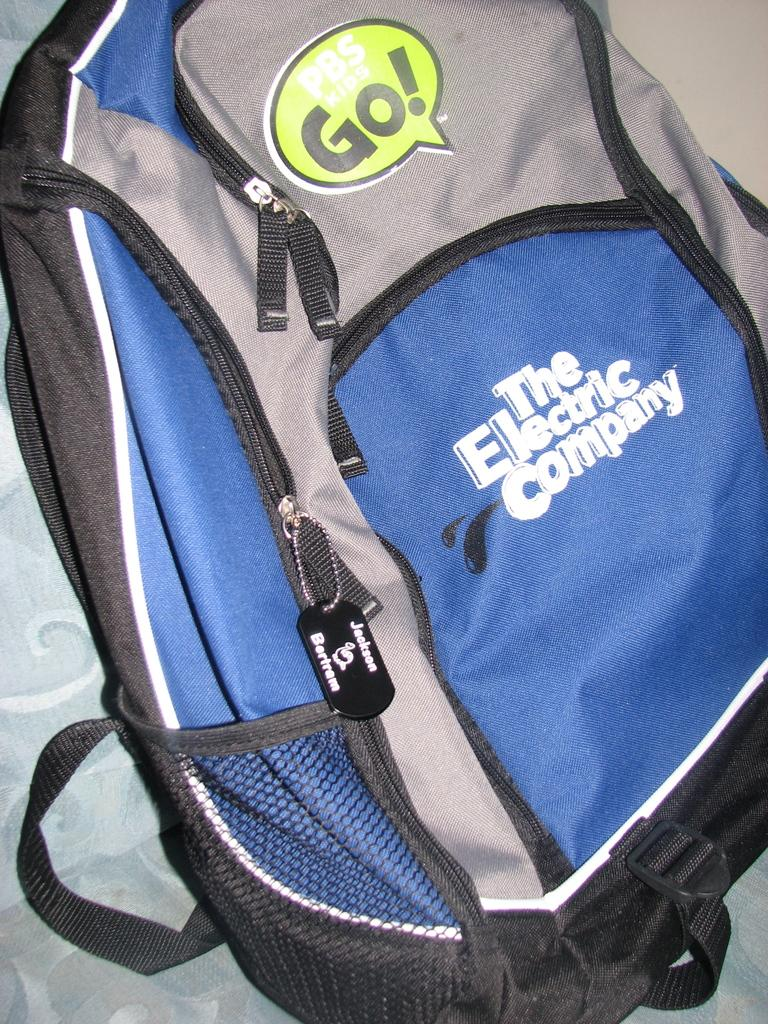<image>
Present a compact description of the photo's key features. A blue and gray back back that has The Electric Company printed on the front. 